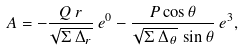<formula> <loc_0><loc_0><loc_500><loc_500>A = - \frac { Q \, r } { \sqrt { \Sigma \, \Delta _ { r } } } \, e ^ { 0 } - \frac { P \cos \theta } { \sqrt { \Sigma \, \Delta _ { \theta } } \, \sin \theta } \, e ^ { 3 } ,</formula> 